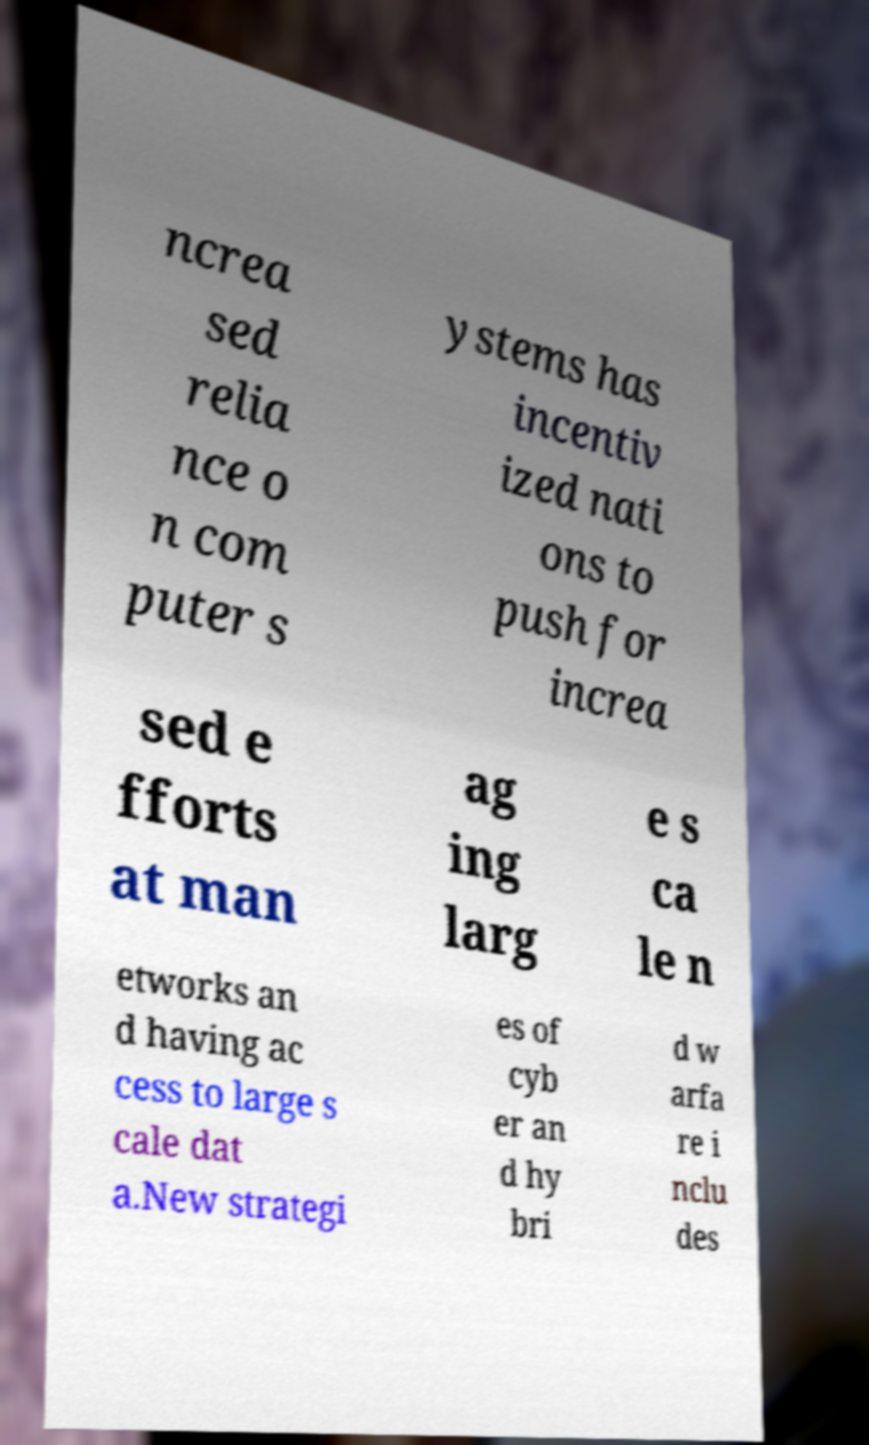Could you extract and type out the text from this image? ncrea sed relia nce o n com puter s ystems has incentiv ized nati ons to push for increa sed e fforts at man ag ing larg e s ca le n etworks an d having ac cess to large s cale dat a.New strategi es of cyb er an d hy bri d w arfa re i nclu des 